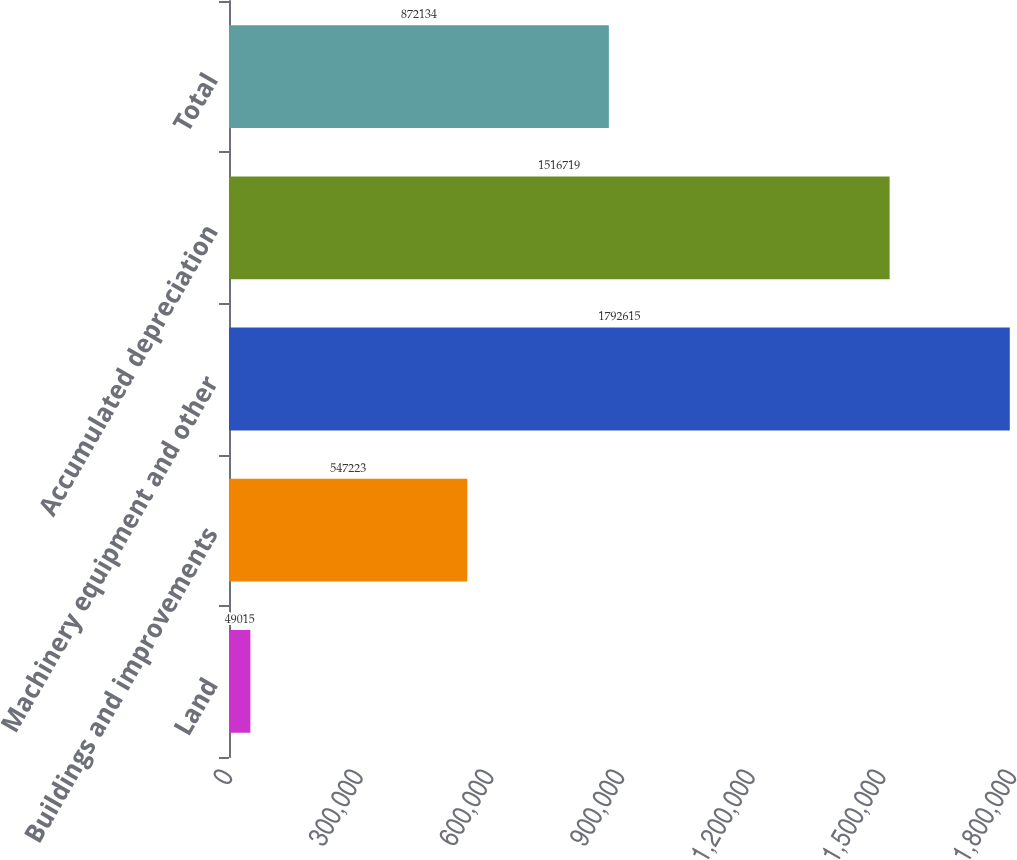<chart> <loc_0><loc_0><loc_500><loc_500><bar_chart><fcel>Land<fcel>Buildings and improvements<fcel>Machinery equipment and other<fcel>Accumulated depreciation<fcel>Total<nl><fcel>49015<fcel>547223<fcel>1.79262e+06<fcel>1.51672e+06<fcel>872134<nl></chart> 